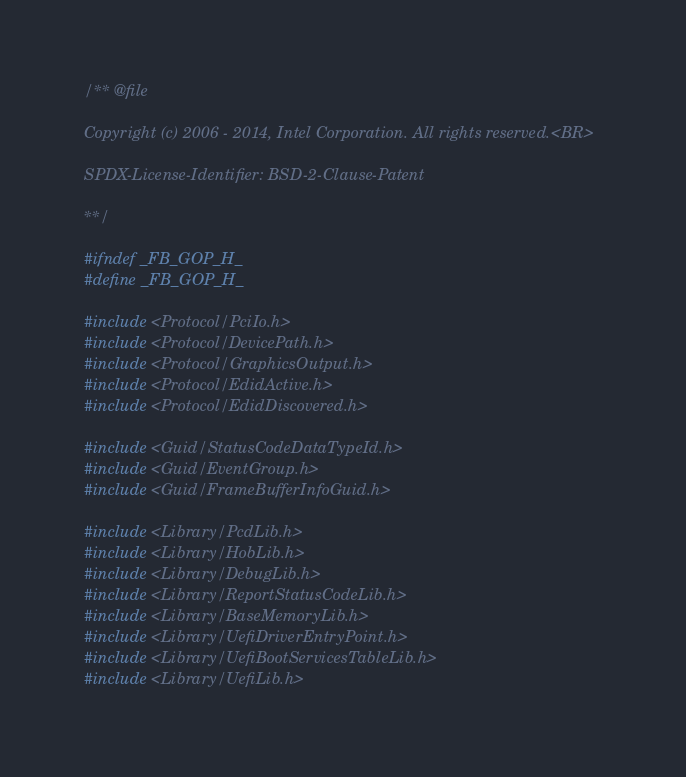<code> <loc_0><loc_0><loc_500><loc_500><_C_>/** @file

Copyright (c) 2006 - 2014, Intel Corporation. All rights reserved.<BR>

SPDX-License-Identifier: BSD-2-Clause-Patent

**/

#ifndef _FB_GOP_H_
#define _FB_GOP_H_

#include <Protocol/PciIo.h>
#include <Protocol/DevicePath.h>
#include <Protocol/GraphicsOutput.h>
#include <Protocol/EdidActive.h>
#include <Protocol/EdidDiscovered.h>

#include <Guid/StatusCodeDataTypeId.h>
#include <Guid/EventGroup.h>
#include <Guid/FrameBufferInfoGuid.h>

#include <Library/PcdLib.h>
#include <Library/HobLib.h>
#include <Library/DebugLib.h>
#include <Library/ReportStatusCodeLib.h>
#include <Library/BaseMemoryLib.h>
#include <Library/UefiDriverEntryPoint.h>
#include <Library/UefiBootServicesTableLib.h>
#include <Library/UefiLib.h></code> 